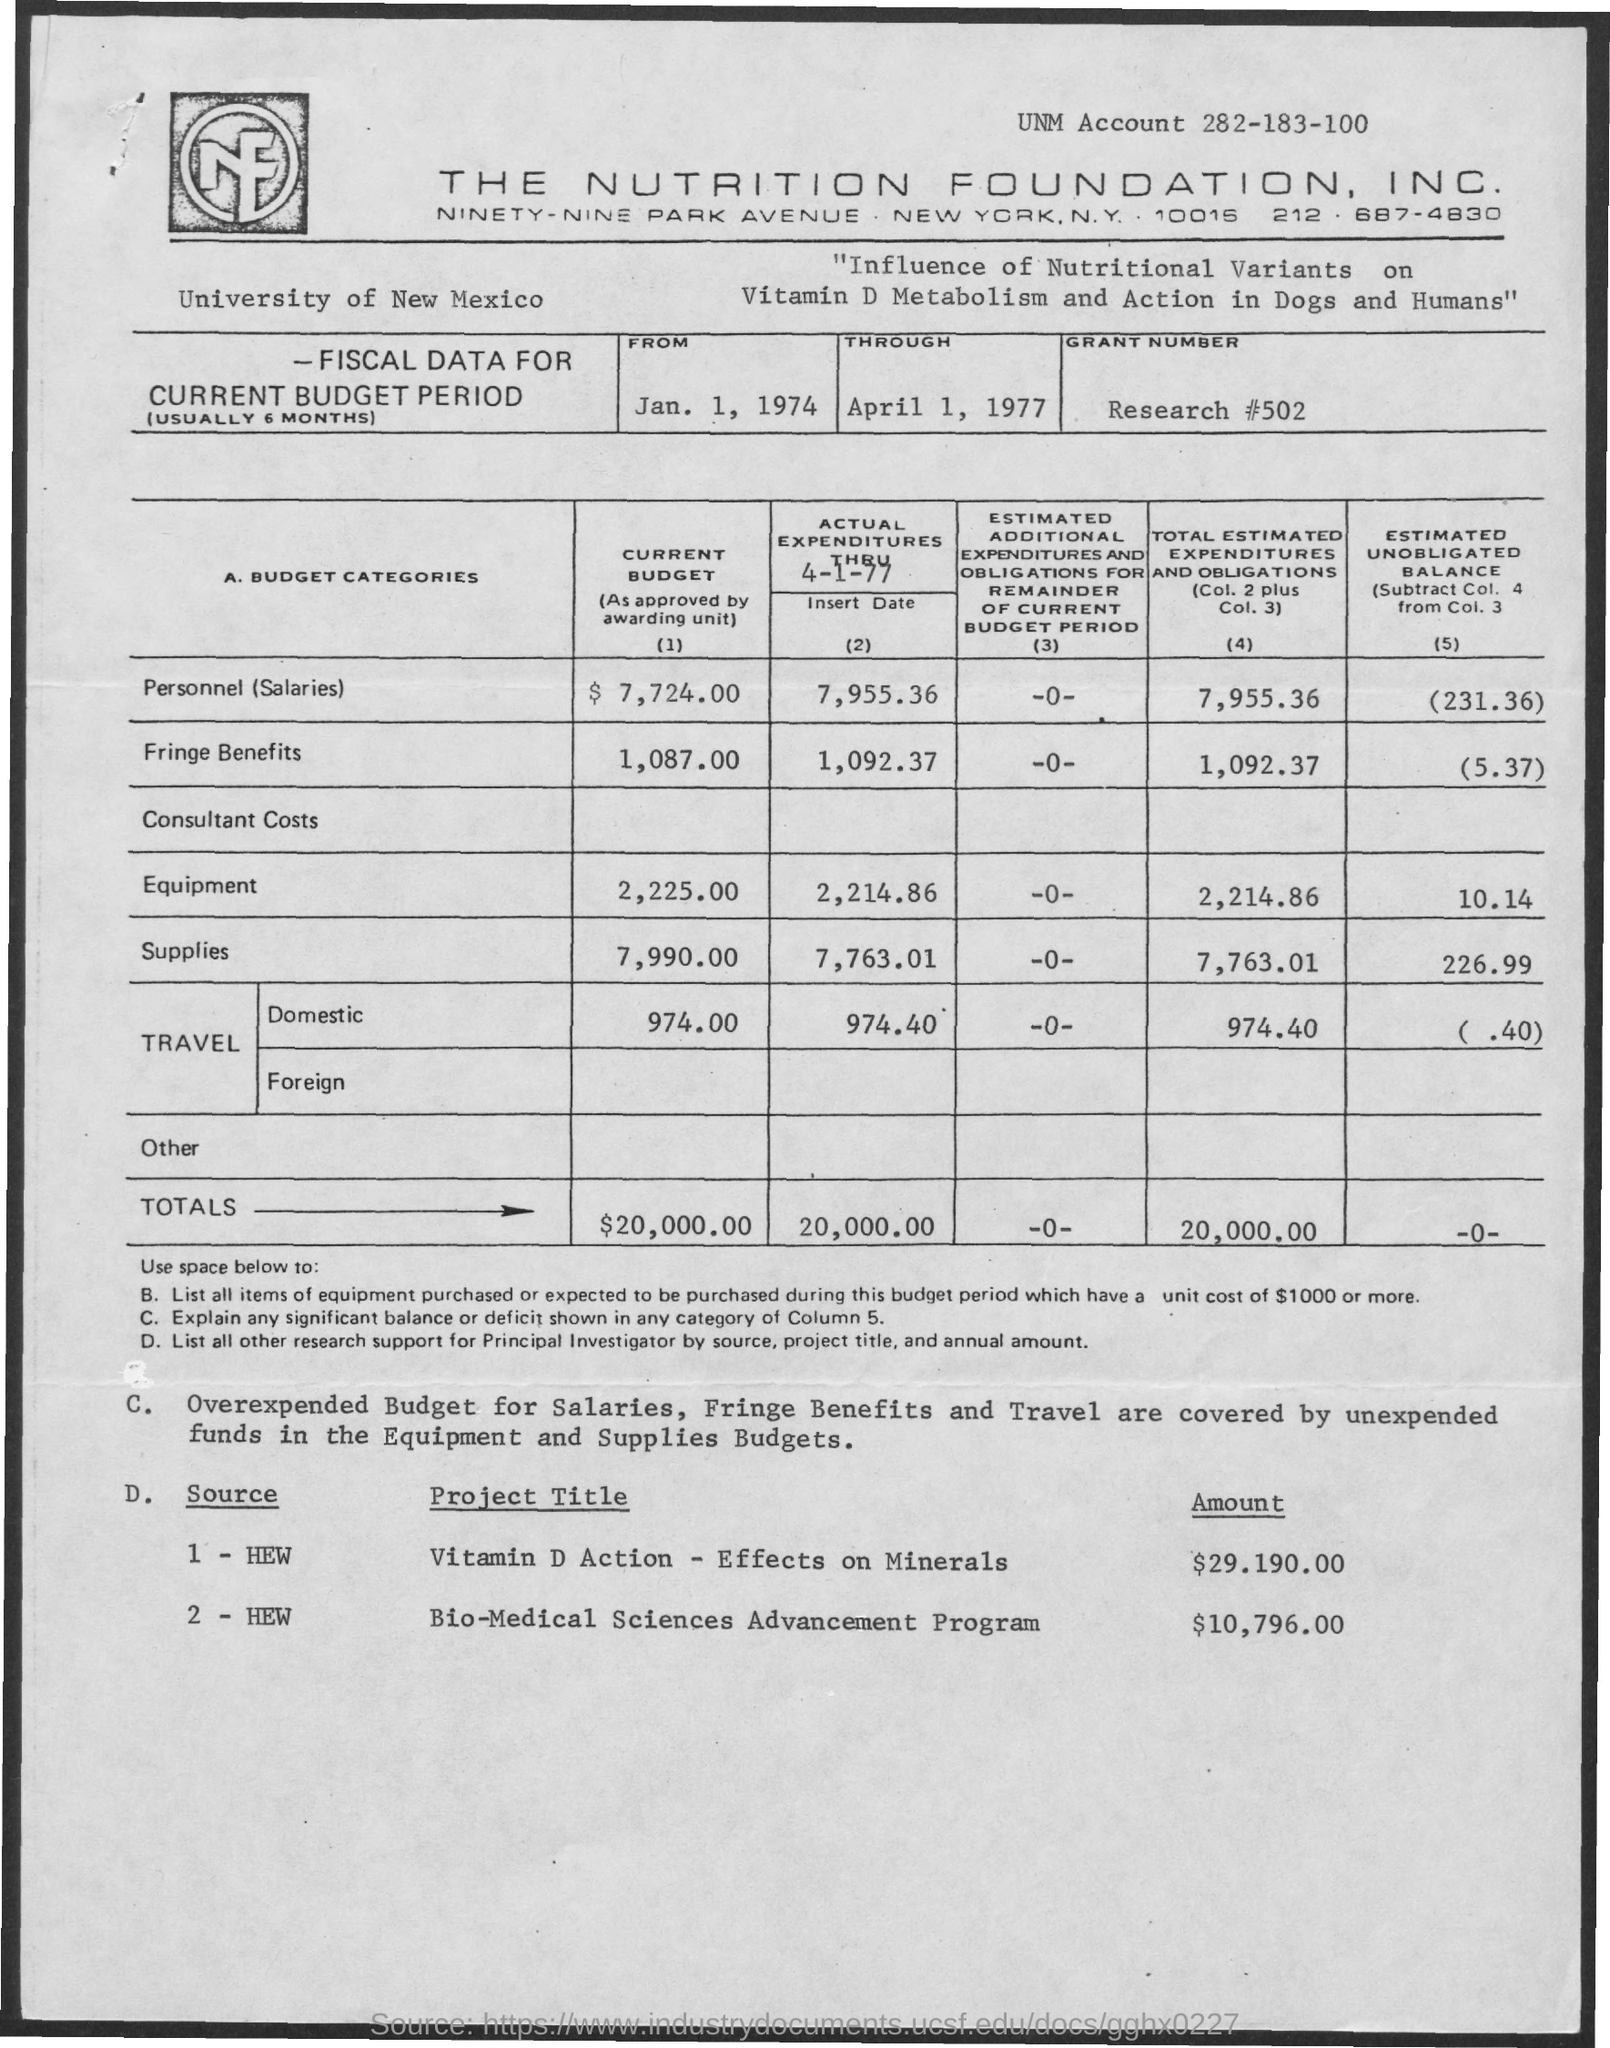What amount is budgeted for the project title "Vitamin D Action Effects on Mineral" ?
Your response must be concise. 29.190.00. What is grant Number?
Your answer should be very brief. Research # 502. 